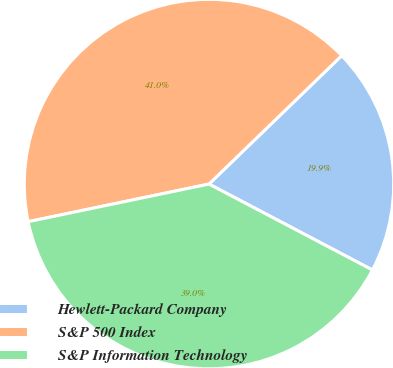Convert chart. <chart><loc_0><loc_0><loc_500><loc_500><pie_chart><fcel>Hewlett-Packard Company<fcel>S&P 500 Index<fcel>S&P Information Technology<nl><fcel>19.94%<fcel>41.03%<fcel>39.03%<nl></chart> 